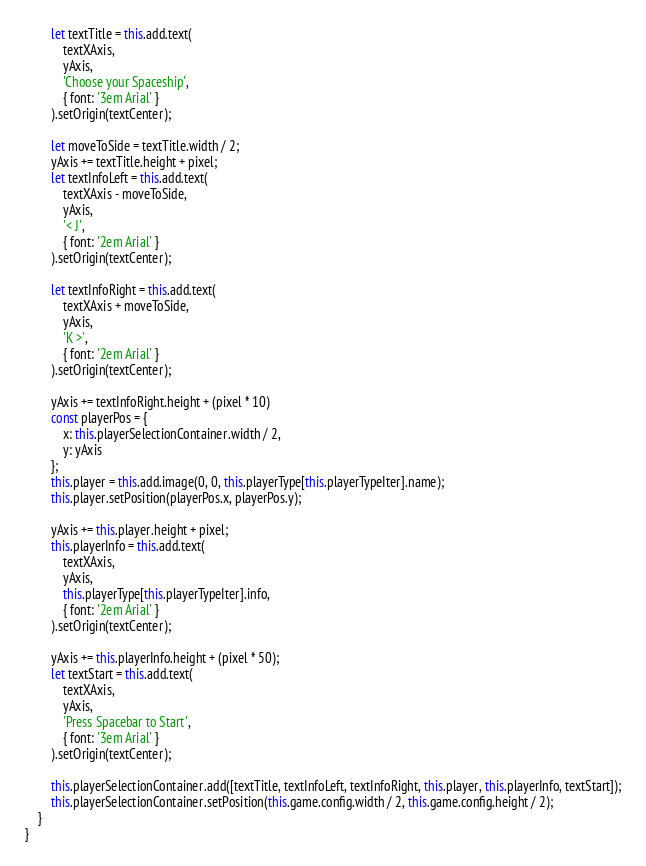<code> <loc_0><loc_0><loc_500><loc_500><_JavaScript_>
		let textTitle = this.add.text(
			textXAxis,
			yAxis,
			'Choose your Spaceship',
			{ font: '3em Arial' }
		).setOrigin(textCenter);

		let moveToSide = textTitle.width / 2;
		yAxis += textTitle.height + pixel;
		let textInfoLeft = this.add.text(
			textXAxis - moveToSide,
			yAxis,
			'< J',
			{ font: '2em Arial' }
		).setOrigin(textCenter);

		let textInfoRight = this.add.text(
			textXAxis + moveToSide,
			yAxis,
			'K >',
			{ font: '2em Arial' }
		).setOrigin(textCenter);

		yAxis += textInfoRight.height + (pixel * 10)
		const playerPos = {
			x: this.playerSelectionContainer.width / 2,
			y: yAxis
		};
		this.player = this.add.image(0, 0, this.playerType[this.playerTypeIter].name);
		this.player.setPosition(playerPos.x, playerPos.y);

		yAxis += this.player.height + pixel;
		this.playerInfo = this.add.text(
			textXAxis,
			yAxis,
			this.playerType[this.playerTypeIter].info,
			{ font: '2em Arial' }
		).setOrigin(textCenter);

		yAxis += this.playerInfo.height + (pixel * 50);
		let textStart = this.add.text(
			textXAxis,
			yAxis,
			'Press Spacebar to Start',
			{ font: '3em Arial' }
		).setOrigin(textCenter);

		this.playerSelectionContainer.add([textTitle, textInfoLeft, textInfoRight, this.player, this.playerInfo, textStart]);
		this.playerSelectionContainer.setPosition(this.game.config.width / 2, this.game.config.height / 2);
	}
}
</code> 